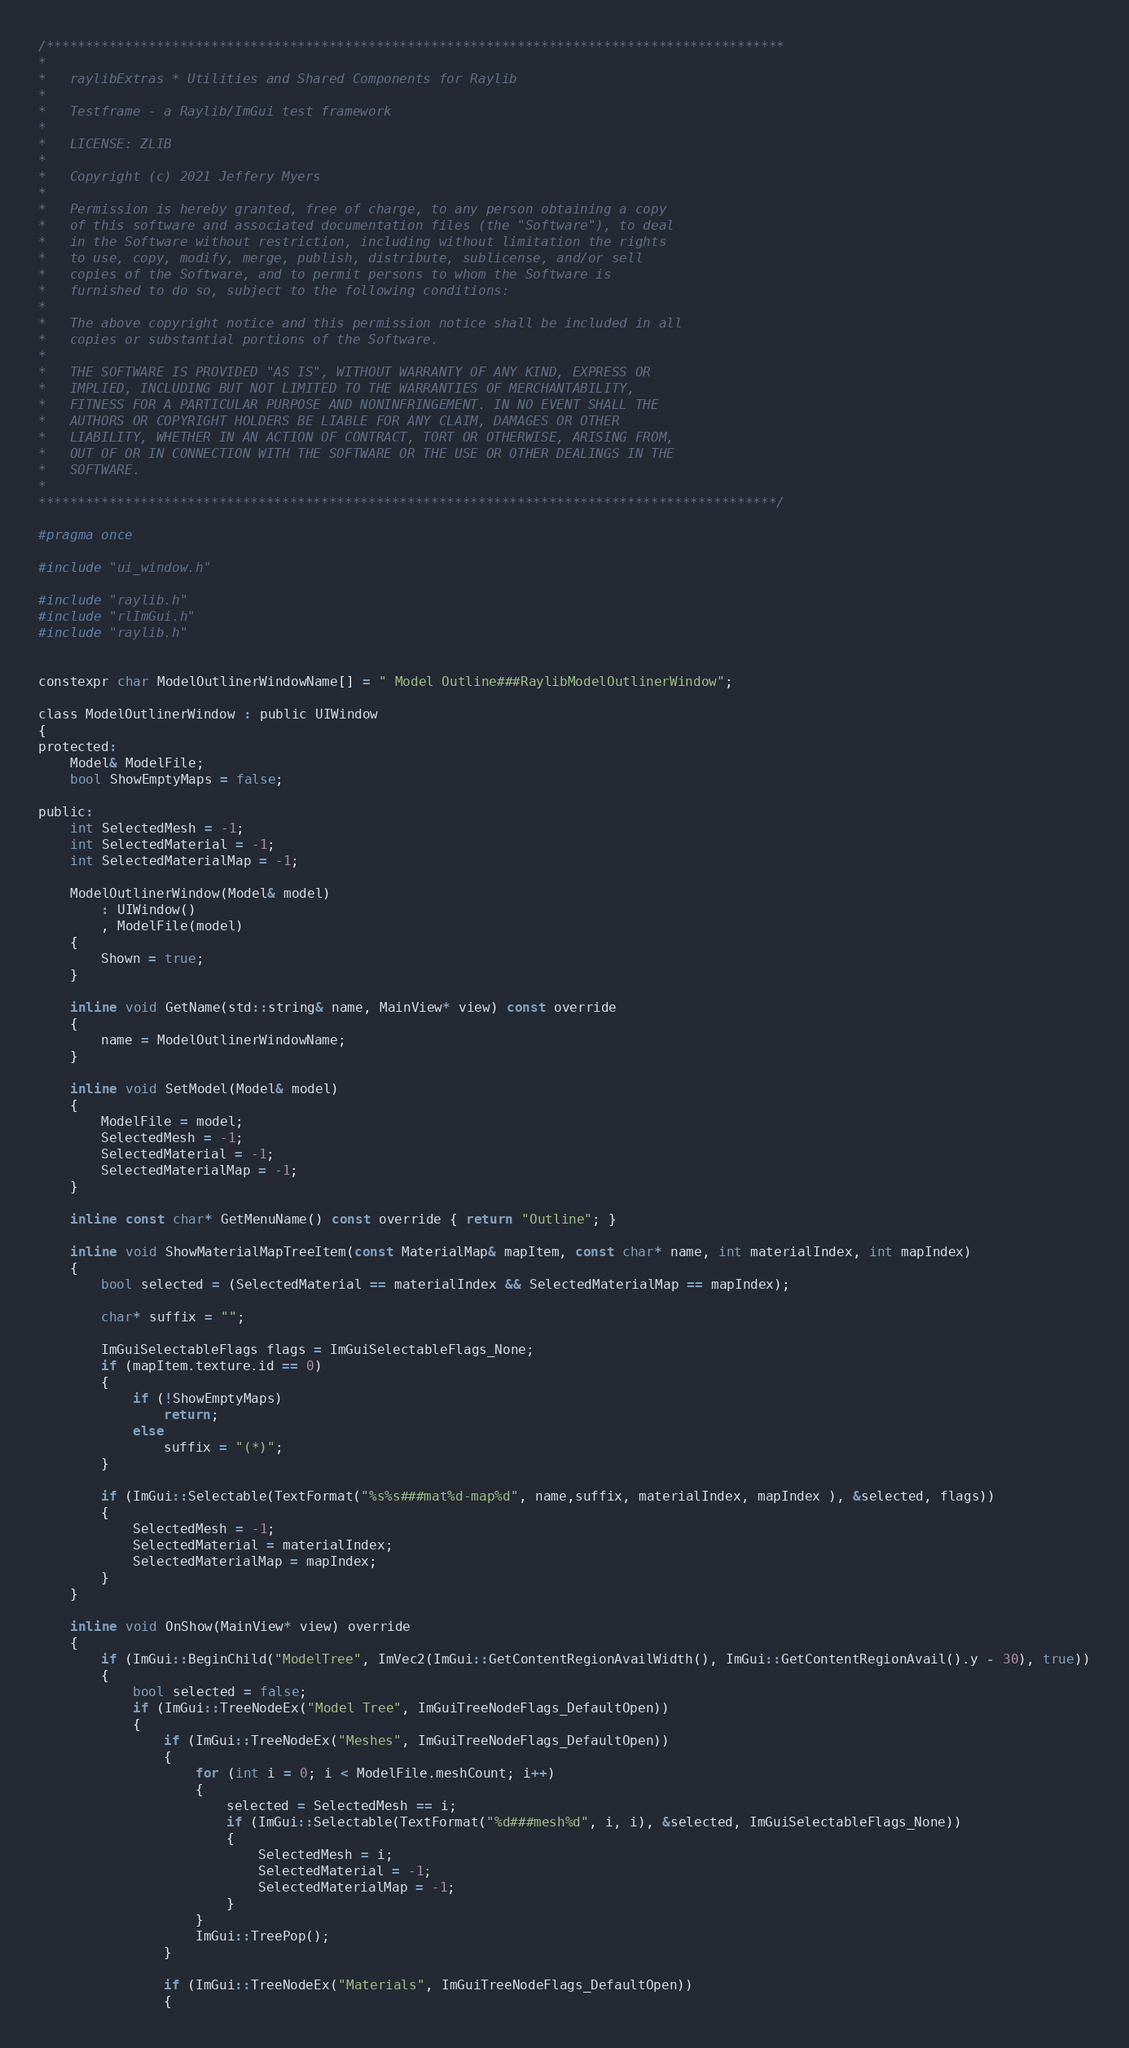Convert code to text. <code><loc_0><loc_0><loc_500><loc_500><_C_>/**********************************************************************************************
*
*   raylibExtras * Utilities and Shared Components for Raylib
*
*   Testframe - a Raylib/ImGui test framework
*
*   LICENSE: ZLIB
*
*   Copyright (c) 2021 Jeffery Myers
*
*   Permission is hereby granted, free of charge, to any person obtaining a copy
*   of this software and associated documentation files (the "Software"), to deal
*   in the Software without restriction, including without limitation the rights
*   to use, copy, modify, merge, publish, distribute, sublicense, and/or sell
*   copies of the Software, and to permit persons to whom the Software is
*   furnished to do so, subject to the following conditions:
*
*   The above copyright notice and this permission notice shall be included in all
*   copies or substantial portions of the Software.
*
*   THE SOFTWARE IS PROVIDED "AS IS", WITHOUT WARRANTY OF ANY KIND, EXPRESS OR
*   IMPLIED, INCLUDING BUT NOT LIMITED TO THE WARRANTIES OF MERCHANTABILITY,
*   FITNESS FOR A PARTICULAR PURPOSE AND NONINFRINGEMENT. IN NO EVENT SHALL THE
*   AUTHORS OR COPYRIGHT HOLDERS BE LIABLE FOR ANY CLAIM, DAMAGES OR OTHER
*   LIABILITY, WHETHER IN AN ACTION OF CONTRACT, TORT OR OTHERWISE, ARISING FROM,
*   OUT OF OR IN CONNECTION WITH THE SOFTWARE OR THE USE OR OTHER DEALINGS IN THE
*   SOFTWARE.
*
**********************************************************************************************/

#pragma once

#include "ui_window.h"

#include "raylib.h"
#include "rlImGui.h"
#include "raylib.h"


constexpr char ModelOutlinerWindowName[] = " Model Outline###RaylibModelOutlinerWindow";

class ModelOutlinerWindow : public UIWindow
{
protected:
    Model& ModelFile;
    bool ShowEmptyMaps = false;

public:
    int SelectedMesh = -1;
    int SelectedMaterial = -1;
    int SelectedMaterialMap = -1;

    ModelOutlinerWindow(Model& model) 
        : UIWindow()
        , ModelFile(model)
    {
        Shown = true;
    }

    inline void GetName(std::string& name, MainView* view) const override
    {
        name = ModelOutlinerWindowName;
    }

    inline void SetModel(Model& model)
    { 
        ModelFile = model;
        SelectedMesh = -1;
        SelectedMaterial = -1;
        SelectedMaterialMap = -1;
    }

    inline const char* GetMenuName() const override { return "Outline"; }

    inline void ShowMaterialMapTreeItem(const MaterialMap& mapItem, const char* name, int materialIndex, int mapIndex)
    {
        bool selected = (SelectedMaterial == materialIndex && SelectedMaterialMap == mapIndex);

        char* suffix = "";

        ImGuiSelectableFlags flags = ImGuiSelectableFlags_None;
        if (mapItem.texture.id == 0)
        {
            if (!ShowEmptyMaps)
                return;
            else
                suffix = "(*)";
        }

        if (ImGui::Selectable(TextFormat("%s%s###mat%d-map%d", name,suffix, materialIndex, mapIndex ), &selected, flags))
        {
            SelectedMesh = -1;
            SelectedMaterial = materialIndex;
            SelectedMaterialMap = mapIndex;
        }
    }

    inline void OnShow(MainView* view) override
    {
        if (ImGui::BeginChild("ModelTree", ImVec2(ImGui::GetContentRegionAvailWidth(), ImGui::GetContentRegionAvail().y - 30), true))
        {
            bool selected = false;
            if (ImGui::TreeNodeEx("Model Tree", ImGuiTreeNodeFlags_DefaultOpen))
            {
                if (ImGui::TreeNodeEx("Meshes", ImGuiTreeNodeFlags_DefaultOpen))
                {
                    for (int i = 0; i < ModelFile.meshCount; i++)
                    {
                        selected = SelectedMesh == i;
                        if (ImGui::Selectable(TextFormat("%d###mesh%d", i, i), &selected, ImGuiSelectableFlags_None))
                        {
                            SelectedMesh = i;
                            SelectedMaterial = -1;
                            SelectedMaterialMap = -1;
                        }
                    }
                    ImGui::TreePop();
                }

                if (ImGui::TreeNodeEx("Materials", ImGuiTreeNodeFlags_DefaultOpen))
                {</code> 